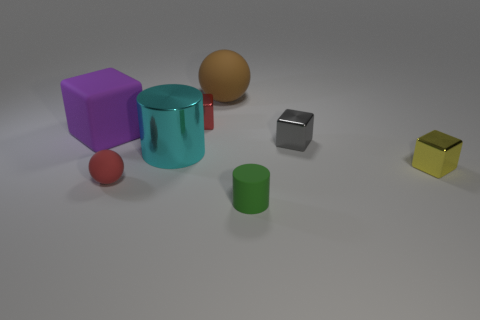Can you tell me the colors of the different objects? Certainly! From left to right, we have a purple cube, a cyan cylinder, a brown sphere, a silver cuboid, a red sphere, and a yellow cube. 